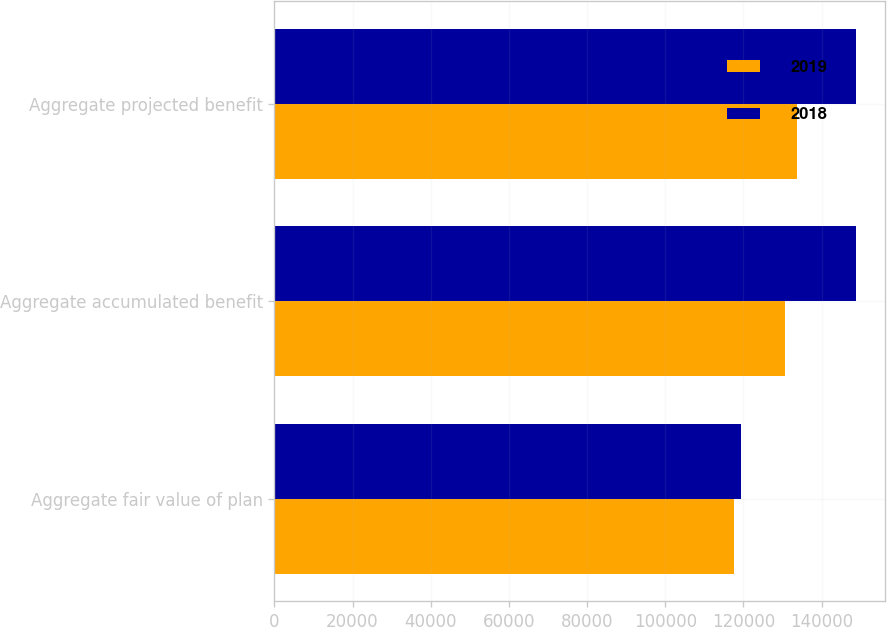<chart> <loc_0><loc_0><loc_500><loc_500><stacked_bar_chart><ecel><fcel>Aggregate fair value of plan<fcel>Aggregate accumulated benefit<fcel>Aggregate projected benefit<nl><fcel>2019<fcel>117504<fcel>130669<fcel>133672<nl><fcel>2018<fcel>119441<fcel>148848<fcel>148848<nl></chart> 